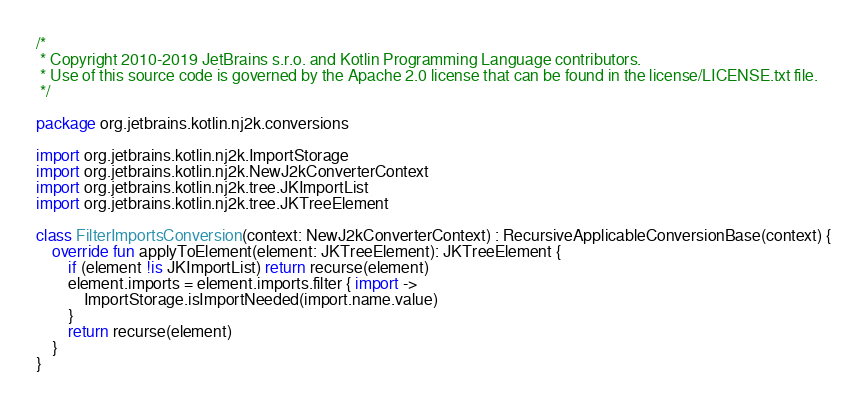Convert code to text. <code><loc_0><loc_0><loc_500><loc_500><_Kotlin_>/*
 * Copyright 2010-2019 JetBrains s.r.o. and Kotlin Programming Language contributors.
 * Use of this source code is governed by the Apache 2.0 license that can be found in the license/LICENSE.txt file.
 */

package org.jetbrains.kotlin.nj2k.conversions

import org.jetbrains.kotlin.nj2k.ImportStorage
import org.jetbrains.kotlin.nj2k.NewJ2kConverterContext
import org.jetbrains.kotlin.nj2k.tree.JKImportList
import org.jetbrains.kotlin.nj2k.tree.JKTreeElement

class FilterImportsConversion(context: NewJ2kConverterContext) : RecursiveApplicableConversionBase(context) {
    override fun applyToElement(element: JKTreeElement): JKTreeElement {
        if (element !is JKImportList) return recurse(element)
        element.imports = element.imports.filter { import ->
            ImportStorage.isImportNeeded(import.name.value)
        }
        return recurse(element)
    }
}</code> 